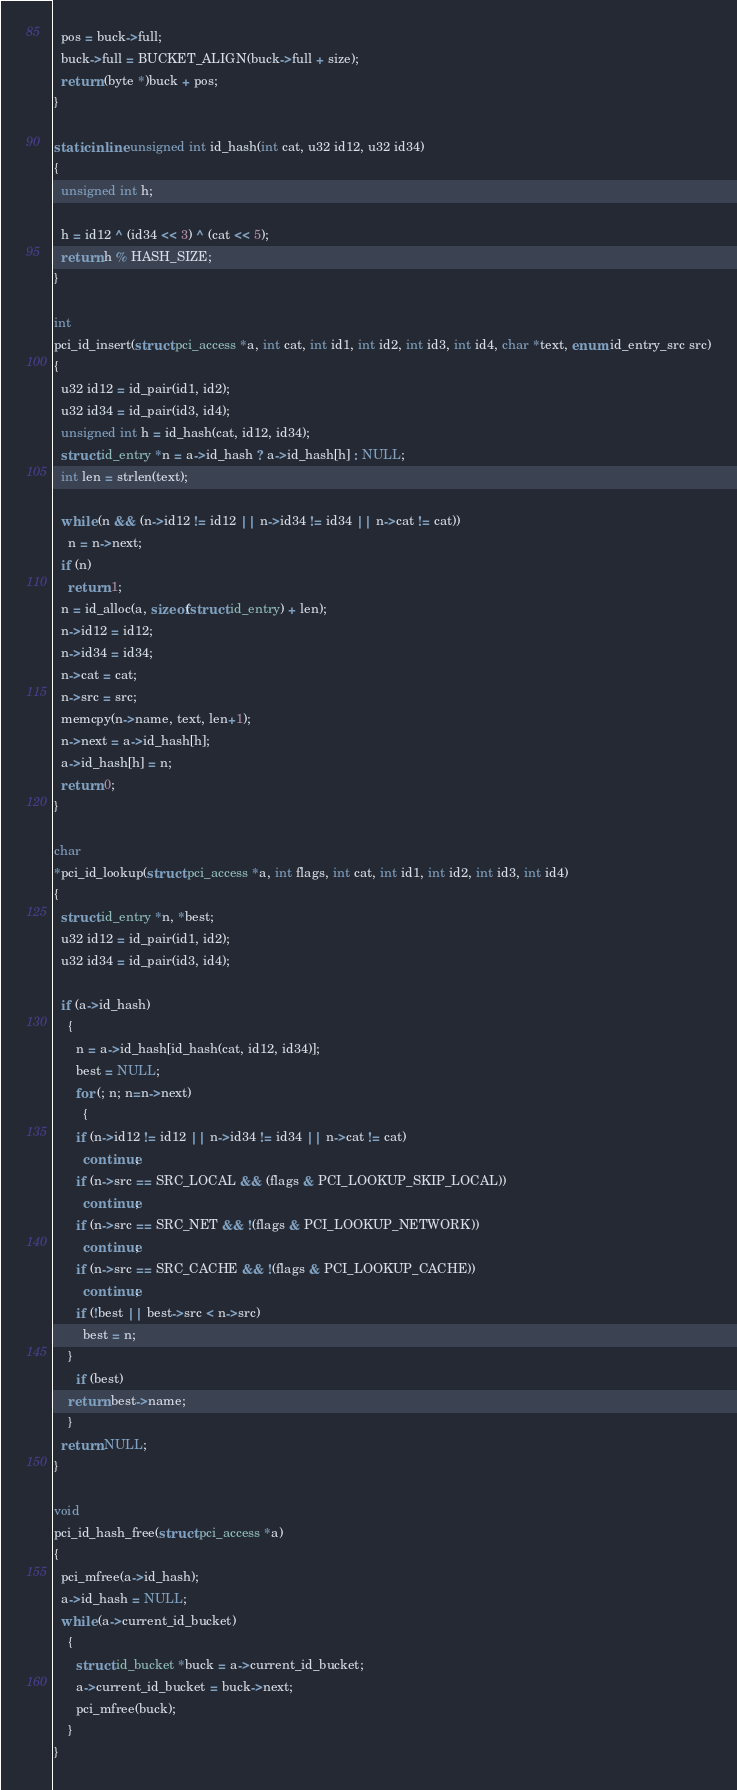<code> <loc_0><loc_0><loc_500><loc_500><_C_>  pos = buck->full;
  buck->full = BUCKET_ALIGN(buck->full + size);
  return (byte *)buck + pos;
}

static inline unsigned int id_hash(int cat, u32 id12, u32 id34)
{
  unsigned int h;

  h = id12 ^ (id34 << 3) ^ (cat << 5);
  return h % HASH_SIZE;
}

int
pci_id_insert(struct pci_access *a, int cat, int id1, int id2, int id3, int id4, char *text, enum id_entry_src src)
{
  u32 id12 = id_pair(id1, id2);
  u32 id34 = id_pair(id3, id4);
  unsigned int h = id_hash(cat, id12, id34);
  struct id_entry *n = a->id_hash ? a->id_hash[h] : NULL;
  int len = strlen(text);

  while (n && (n->id12 != id12 || n->id34 != id34 || n->cat != cat))
    n = n->next;
  if (n)
    return 1;
  n = id_alloc(a, sizeof(struct id_entry) + len);
  n->id12 = id12;
  n->id34 = id34;
  n->cat = cat;
  n->src = src;
  memcpy(n->name, text, len+1);
  n->next = a->id_hash[h];
  a->id_hash[h] = n;
  return 0;
}

char
*pci_id_lookup(struct pci_access *a, int flags, int cat, int id1, int id2, int id3, int id4)
{
  struct id_entry *n, *best;
  u32 id12 = id_pair(id1, id2);
  u32 id34 = id_pair(id3, id4);

  if (a->id_hash)
    {
      n = a->id_hash[id_hash(cat, id12, id34)];
      best = NULL;
      for (; n; n=n->next)
        {
	  if (n->id12 != id12 || n->id34 != id34 || n->cat != cat)
	    continue;
	  if (n->src == SRC_LOCAL && (flags & PCI_LOOKUP_SKIP_LOCAL))
	    continue;
	  if (n->src == SRC_NET && !(flags & PCI_LOOKUP_NETWORK))
	    continue;
	  if (n->src == SRC_CACHE && !(flags & PCI_LOOKUP_CACHE))
	    continue;
	  if (!best || best->src < n->src)
	    best = n;
	}
      if (best)
	return best->name;
    }
  return NULL;
}

void
pci_id_hash_free(struct pci_access *a)
{
  pci_mfree(a->id_hash);
  a->id_hash = NULL;
  while (a->current_id_bucket)
    {
      struct id_bucket *buck = a->current_id_bucket;
      a->current_id_bucket = buck->next;
      pci_mfree(buck);
    }
}
</code> 